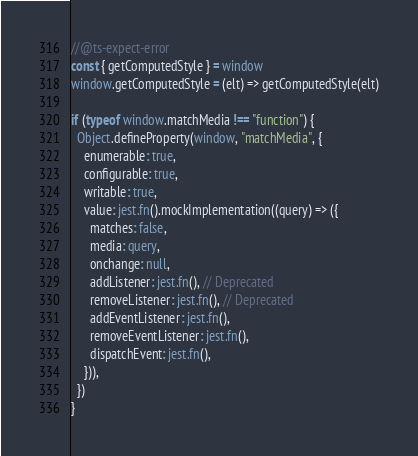<code> <loc_0><loc_0><loc_500><loc_500><_TypeScript_>//@ts-expect-error
const { getComputedStyle } = window
window.getComputedStyle = (elt) => getComputedStyle(elt)

if (typeof window.matchMedia !== "function") {
  Object.defineProperty(window, "matchMedia", {
    enumerable: true,
    configurable: true,
    writable: true,
    value: jest.fn().mockImplementation((query) => ({
      matches: false,
      media: query,
      onchange: null,
      addListener: jest.fn(), // Deprecated
      removeListener: jest.fn(), // Deprecated
      addEventListener: jest.fn(),
      removeEventListener: jest.fn(),
      dispatchEvent: jest.fn(),
    })),
  })
}
</code> 